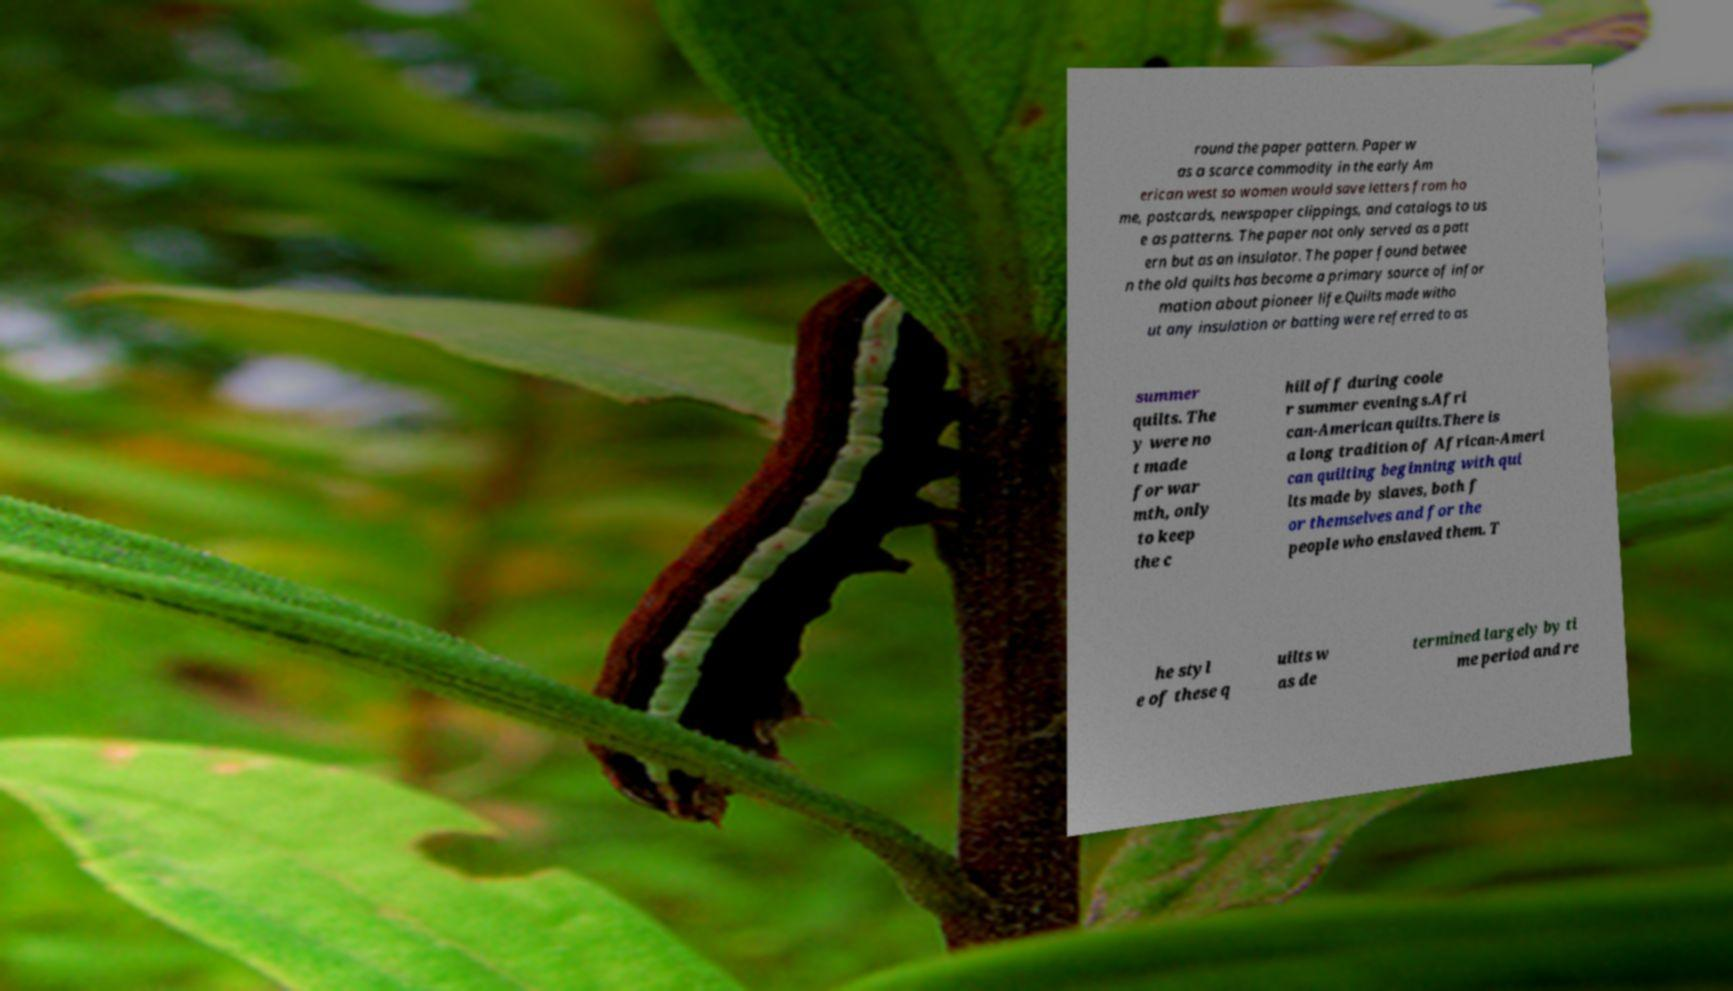Can you read and provide the text displayed in the image?This photo seems to have some interesting text. Can you extract and type it out for me? round the paper pattern. Paper w as a scarce commodity in the early Am erican west so women would save letters from ho me, postcards, newspaper clippings, and catalogs to us e as patterns. The paper not only served as a patt ern but as an insulator. The paper found betwee n the old quilts has become a primary source of infor mation about pioneer life.Quilts made witho ut any insulation or batting were referred to as summer quilts. The y were no t made for war mth, only to keep the c hill off during coole r summer evenings.Afri can-American quilts.There is a long tradition of African-Ameri can quilting beginning with qui lts made by slaves, both f or themselves and for the people who enslaved them. T he styl e of these q uilts w as de termined largely by ti me period and re 